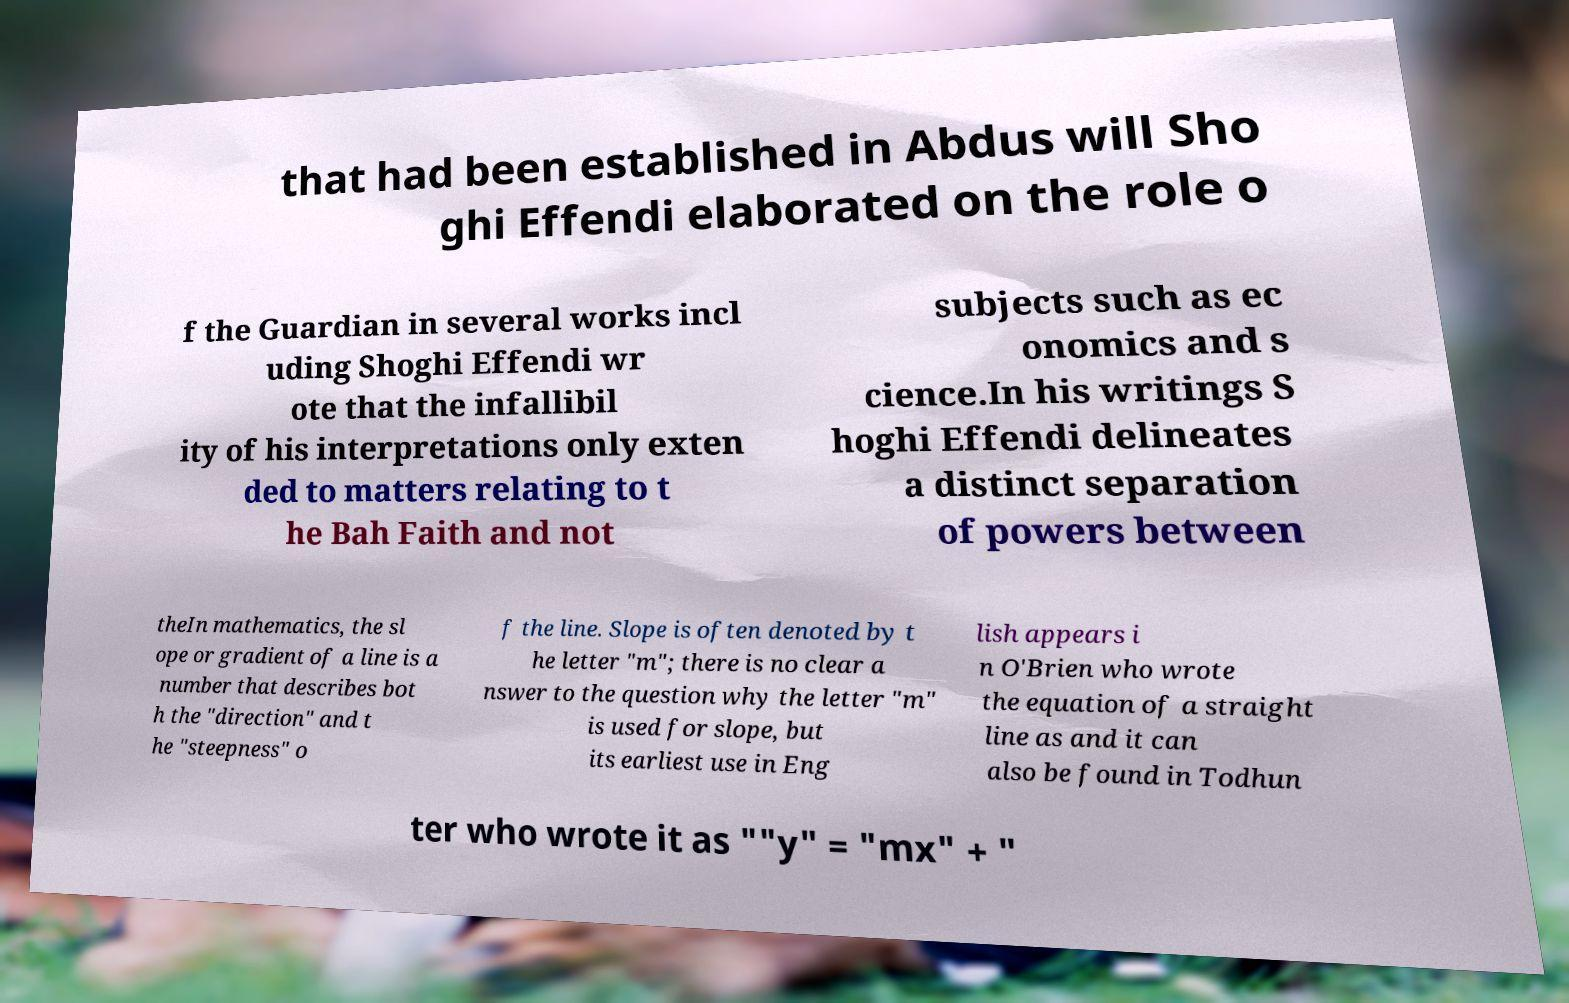For documentation purposes, I need the text within this image transcribed. Could you provide that? that had been established in Abdus will Sho ghi Effendi elaborated on the role o f the Guardian in several works incl uding Shoghi Effendi wr ote that the infallibil ity of his interpretations only exten ded to matters relating to t he Bah Faith and not subjects such as ec onomics and s cience.In his writings S hoghi Effendi delineates a distinct separation of powers between theIn mathematics, the sl ope or gradient of a line is a number that describes bot h the "direction" and t he "steepness" o f the line. Slope is often denoted by t he letter "m"; there is no clear a nswer to the question why the letter "m" is used for slope, but its earliest use in Eng lish appears i n O'Brien who wrote the equation of a straight line as and it can also be found in Todhun ter who wrote it as ""y" = "mx" + " 